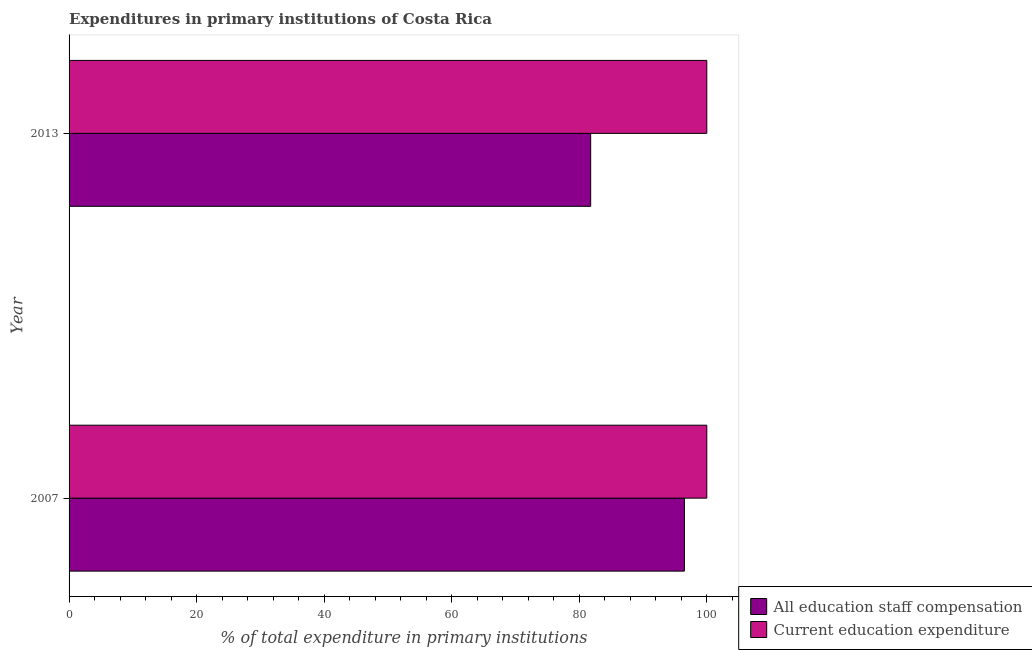How many bars are there on the 2nd tick from the top?
Your answer should be very brief. 2. In how many cases, is the number of bars for a given year not equal to the number of legend labels?
Make the answer very short. 0. What is the expenditure in education in 2013?
Offer a very short reply. 100. Across all years, what is the maximum expenditure in staff compensation?
Your answer should be compact. 96.49. Across all years, what is the minimum expenditure in staff compensation?
Provide a succinct answer. 81.79. In which year was the expenditure in education maximum?
Your answer should be compact. 2007. What is the total expenditure in staff compensation in the graph?
Keep it short and to the point. 178.28. What is the difference between the expenditure in staff compensation in 2007 and that in 2013?
Provide a short and direct response. 14.7. What is the difference between the expenditure in staff compensation in 2013 and the expenditure in education in 2007?
Your answer should be compact. -18.21. In the year 2013, what is the difference between the expenditure in education and expenditure in staff compensation?
Offer a terse response. 18.21. What is the ratio of the expenditure in staff compensation in 2007 to that in 2013?
Offer a terse response. 1.18. Is the expenditure in staff compensation in 2007 less than that in 2013?
Your answer should be very brief. No. What does the 1st bar from the top in 2007 represents?
Give a very brief answer. Current education expenditure. What does the 2nd bar from the bottom in 2007 represents?
Your answer should be very brief. Current education expenditure. What is the difference between two consecutive major ticks on the X-axis?
Your response must be concise. 20. Does the graph contain grids?
Give a very brief answer. No. Where does the legend appear in the graph?
Offer a terse response. Bottom right. How are the legend labels stacked?
Your answer should be compact. Vertical. What is the title of the graph?
Your answer should be compact. Expenditures in primary institutions of Costa Rica. Does "Number of departures" appear as one of the legend labels in the graph?
Offer a very short reply. No. What is the label or title of the X-axis?
Your response must be concise. % of total expenditure in primary institutions. What is the % of total expenditure in primary institutions of All education staff compensation in 2007?
Provide a short and direct response. 96.49. What is the % of total expenditure in primary institutions of All education staff compensation in 2013?
Offer a very short reply. 81.79. Across all years, what is the maximum % of total expenditure in primary institutions in All education staff compensation?
Provide a succinct answer. 96.49. Across all years, what is the maximum % of total expenditure in primary institutions in Current education expenditure?
Offer a terse response. 100. Across all years, what is the minimum % of total expenditure in primary institutions in All education staff compensation?
Offer a terse response. 81.79. Across all years, what is the minimum % of total expenditure in primary institutions of Current education expenditure?
Your answer should be compact. 100. What is the total % of total expenditure in primary institutions in All education staff compensation in the graph?
Offer a very short reply. 178.28. What is the total % of total expenditure in primary institutions in Current education expenditure in the graph?
Ensure brevity in your answer.  200. What is the difference between the % of total expenditure in primary institutions of All education staff compensation in 2007 and that in 2013?
Provide a succinct answer. 14.7. What is the difference between the % of total expenditure in primary institutions in All education staff compensation in 2007 and the % of total expenditure in primary institutions in Current education expenditure in 2013?
Ensure brevity in your answer.  -3.51. What is the average % of total expenditure in primary institutions of All education staff compensation per year?
Your answer should be very brief. 89.14. What is the average % of total expenditure in primary institutions in Current education expenditure per year?
Make the answer very short. 100. In the year 2007, what is the difference between the % of total expenditure in primary institutions of All education staff compensation and % of total expenditure in primary institutions of Current education expenditure?
Give a very brief answer. -3.51. In the year 2013, what is the difference between the % of total expenditure in primary institutions in All education staff compensation and % of total expenditure in primary institutions in Current education expenditure?
Offer a terse response. -18.21. What is the ratio of the % of total expenditure in primary institutions of All education staff compensation in 2007 to that in 2013?
Provide a succinct answer. 1.18. What is the difference between the highest and the second highest % of total expenditure in primary institutions in All education staff compensation?
Keep it short and to the point. 14.7. What is the difference between the highest and the second highest % of total expenditure in primary institutions of Current education expenditure?
Your answer should be very brief. 0. What is the difference between the highest and the lowest % of total expenditure in primary institutions in All education staff compensation?
Your answer should be very brief. 14.7. 